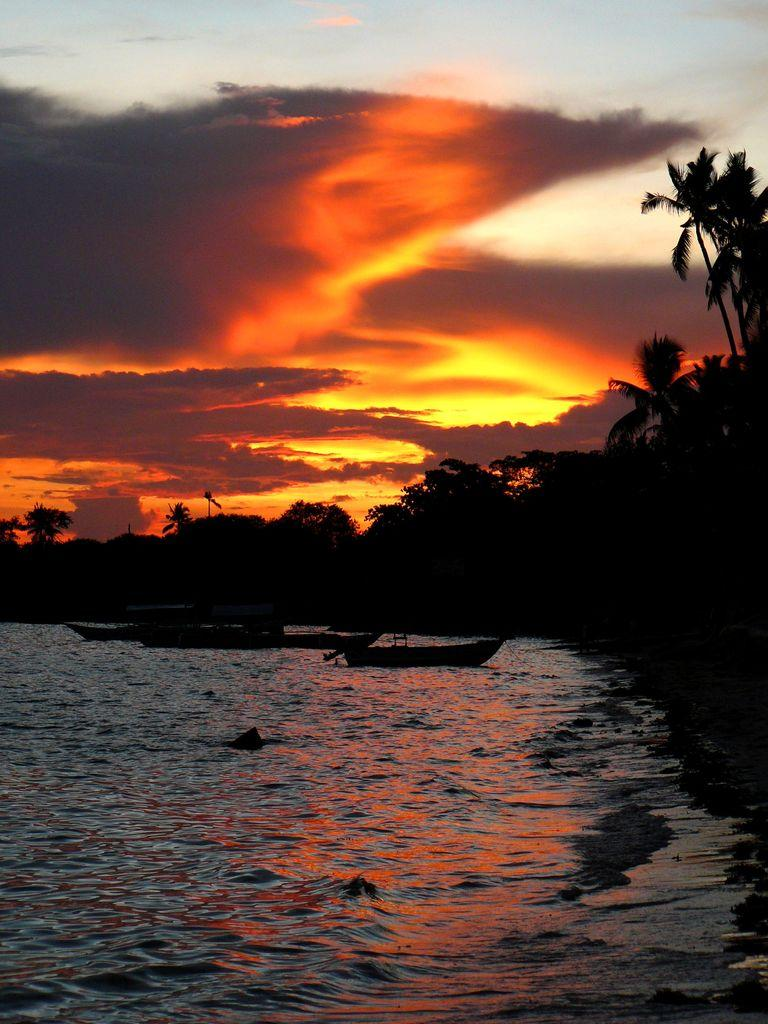What is the main subject of the image? The main subject of the image is boats. Where are the boats located? The boats are on the water. What can be seen behind the water in the image? There is a group of trees visible behind the water. What is visible at the top of the image? The sky is visible at the top of the image. What type of cracker is being used to generate ideas in the image? There is no cracker or idea generation activity present in the image. What selection of items can be seen on the boats in the image? The image does not show any specific items on the boats, only the boats themselves are visible. 